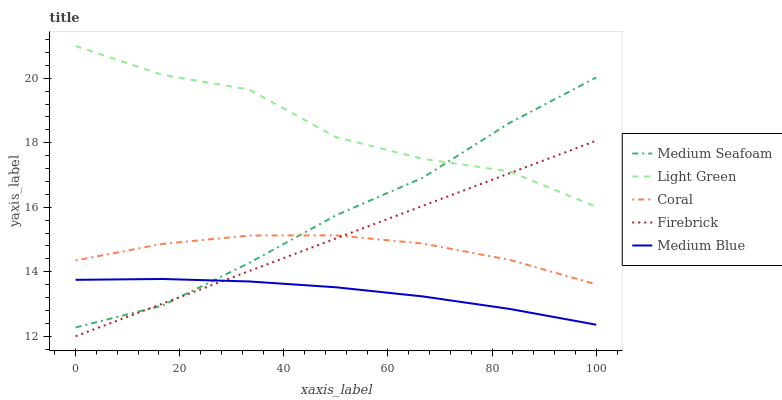Does Medium Blue have the minimum area under the curve?
Answer yes or no. Yes. Does Light Green have the maximum area under the curve?
Answer yes or no. Yes. Does Coral have the minimum area under the curve?
Answer yes or no. No. Does Coral have the maximum area under the curve?
Answer yes or no. No. Is Firebrick the smoothest?
Answer yes or no. Yes. Is Light Green the roughest?
Answer yes or no. Yes. Is Coral the smoothest?
Answer yes or no. No. Is Coral the roughest?
Answer yes or no. No. Does Coral have the lowest value?
Answer yes or no. No. Does Light Green have the highest value?
Answer yes or no. Yes. Does Coral have the highest value?
Answer yes or no. No. Is Medium Blue less than Coral?
Answer yes or no. Yes. Is Light Green greater than Medium Blue?
Answer yes or no. Yes. Does Medium Blue intersect Firebrick?
Answer yes or no. Yes. Is Medium Blue less than Firebrick?
Answer yes or no. No. Is Medium Blue greater than Firebrick?
Answer yes or no. No. Does Medium Blue intersect Coral?
Answer yes or no. No. 